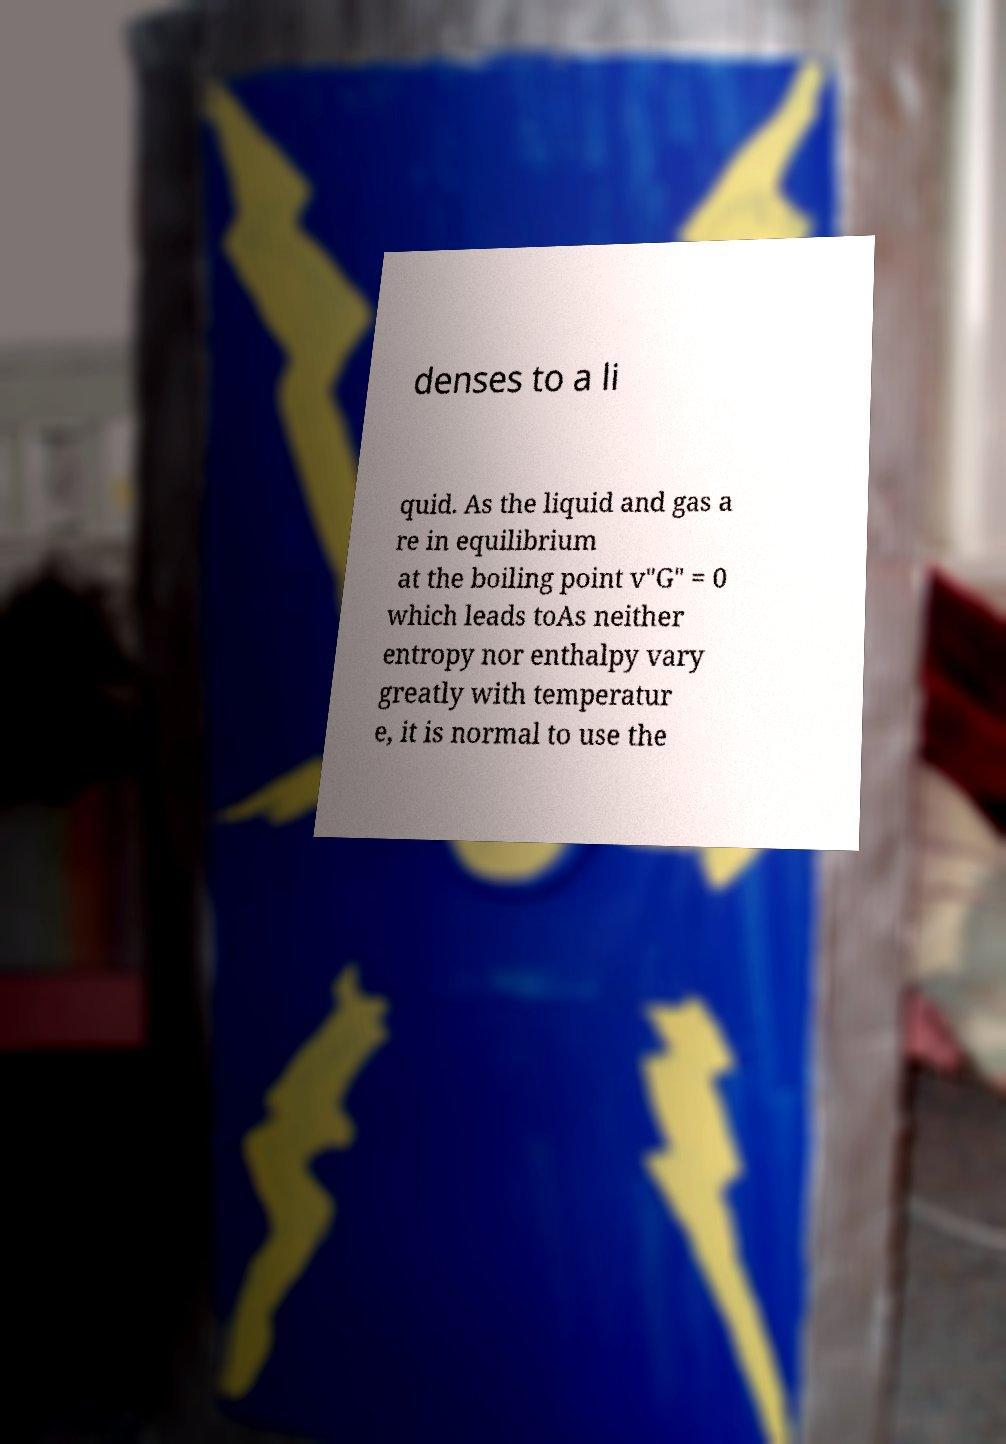For documentation purposes, I need the text within this image transcribed. Could you provide that? denses to a li quid. As the liquid and gas a re in equilibrium at the boiling point v"G" = 0 which leads toAs neither entropy nor enthalpy vary greatly with temperatur e, it is normal to use the 